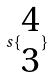<formula> <loc_0><loc_0><loc_500><loc_500>s \{ \begin{matrix} 4 \\ 3 \end{matrix} \}</formula> 